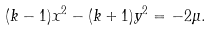Convert formula to latex. <formula><loc_0><loc_0><loc_500><loc_500>( k - 1 ) x ^ { 2 } - ( k + 1 ) y ^ { 2 } = - 2 \mu .</formula> 